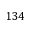Convert formula to latex. <formula><loc_0><loc_0><loc_500><loc_500>1 3 4</formula> 